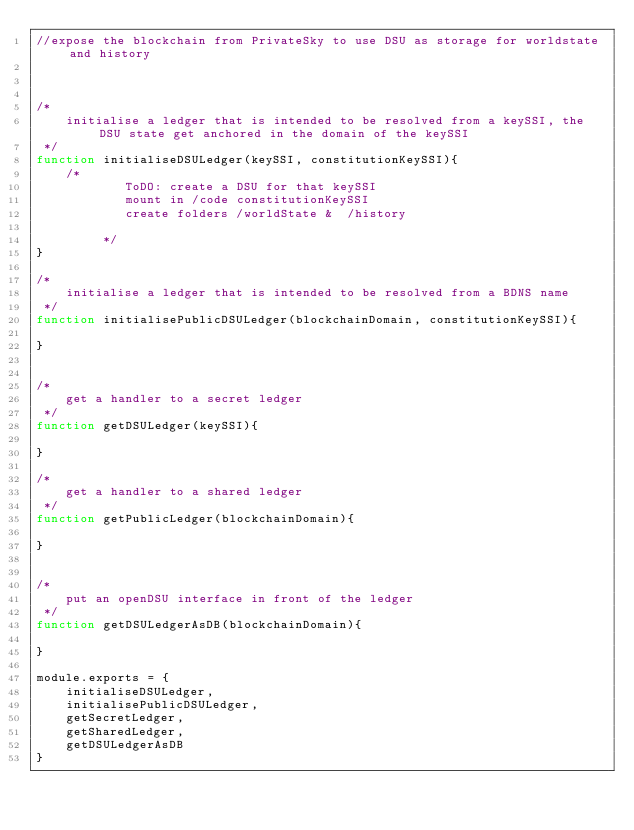Convert code to text. <code><loc_0><loc_0><loc_500><loc_500><_JavaScript_>//expose the blockchain from PrivateSky to use DSU as storage for worldstate and history



/*
    initialise a ledger that is intended to be resolved from a keySSI, the DSU state get anchored in the domain of the keySSI
 */
function initialiseDSULedger(keySSI, constitutionKeySSI){
    /*
            ToDO: create a DSU for that keySSI
            mount in /code constitutionKeySSI
            create folders /worldState &  /history

         */
}

/*
    initialise a ledger that is intended to be resolved from a BDNS name
 */
function initialisePublicDSULedger(blockchainDomain, constitutionKeySSI){

}


/*
    get a handler to a secret ledger
 */
function getDSULedger(keySSI){

}

/*
    get a handler to a shared ledger
 */
function getPublicLedger(blockchainDomain){

}


/*
    put an openDSU interface in front of the ledger
 */
function getDSULedgerAsDB(blockchainDomain){

}

module.exports = {
    initialiseDSULedger,
    initialisePublicDSULedger,
    getSecretLedger,
    getSharedLedger,
    getDSULedgerAsDB
}
</code> 